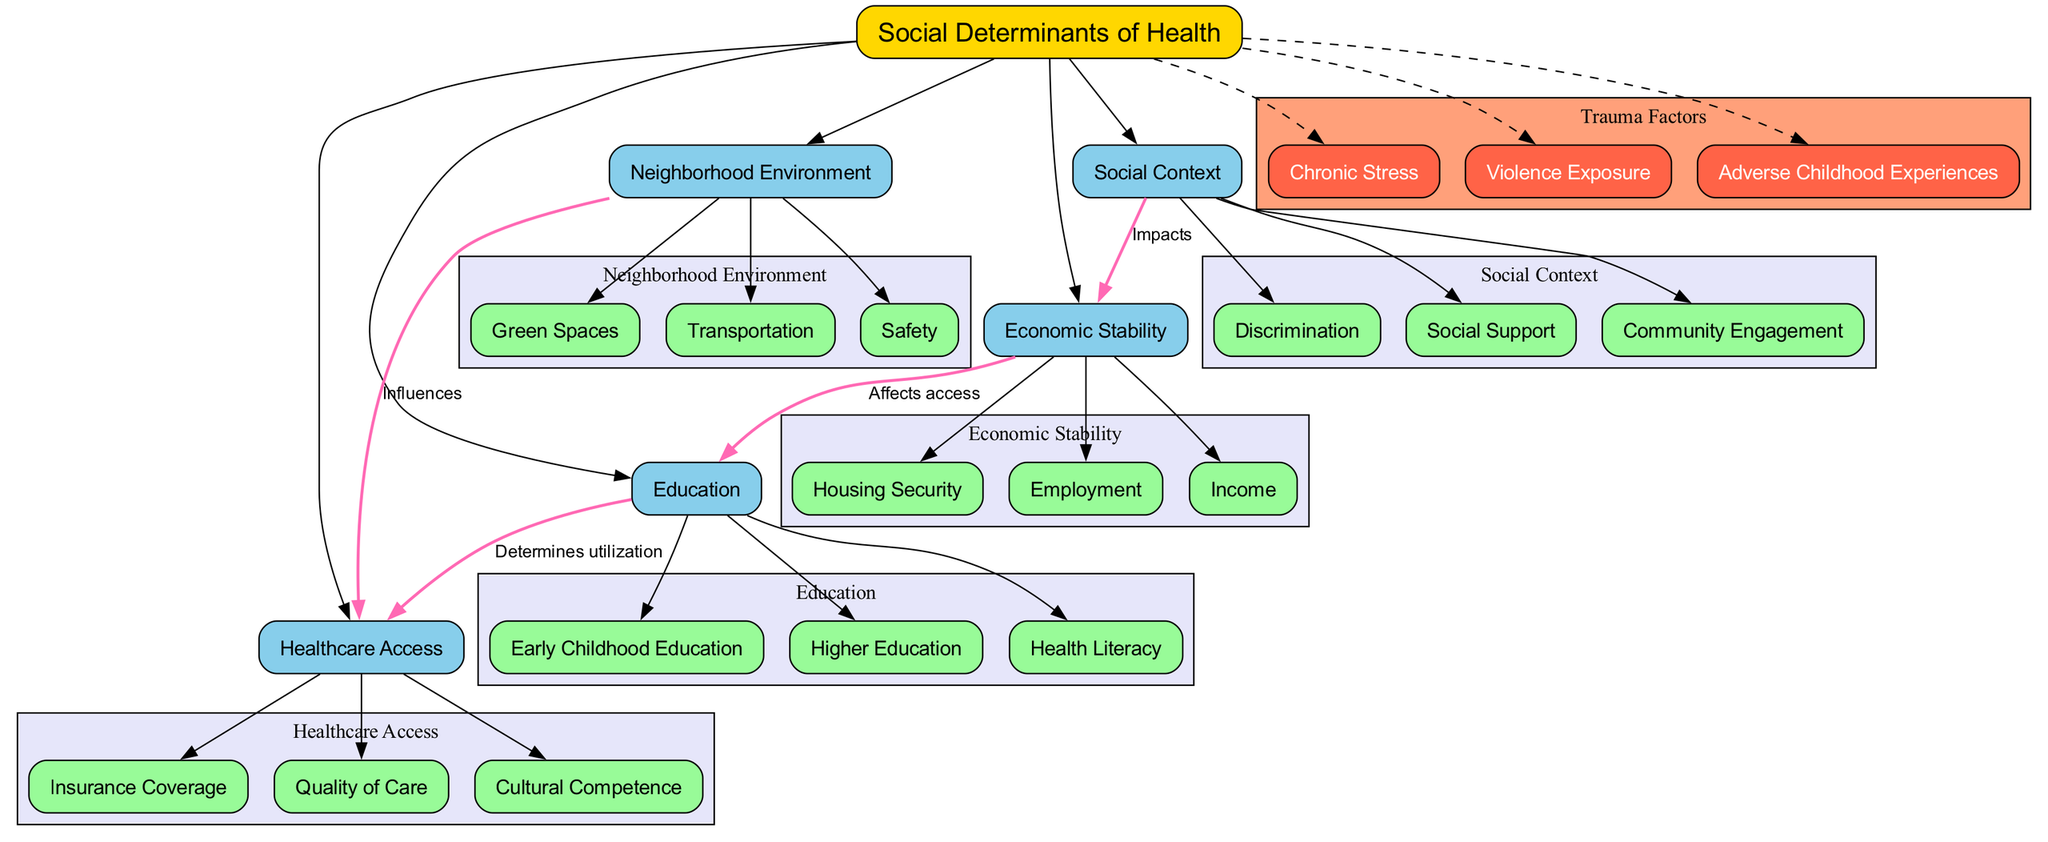What is the central topic of the diagram? The diagram explicitly states the central topic in the center node, labeled as "Social Determinants of Health."
Answer: Social Determinants of Health How many main categories are there in the diagram? By counting the nodes connected to the central topic, there are five main categories listed.
Answer: 5 What is one sub-element of Economic Stability? The diagram lists three sub-elements under Economic Stability; one of them, "Employment," can be identified.
Answer: Employment What type of connection exists between Neighborhood Environment and Healthcare Access? The connection is labeled as "Influences," indicating the nature of the relationship as visualized in the diagram.
Answer: Influences Which category affects access to Education? The diagram shows an edge connecting Economic Stability to Education, indicating that it affects access to Education.
Answer: Economic Stability What are the trauma factors listed in the diagram? The diagram provides three specific factors relating to trauma that can be directly found in the trauma factors cluster.
Answer: Chronic Stress, Violence Exposure, Adverse Childhood Experiences Which main category determines utilization of Healthcare Access? The diagram indicates that Education is the category that determines utilization of Healthcare Access, as noted by the connection labeled "Determines utilization."
Answer: Education How are Social Context and Economic Stability related? The diagram demonstrates a direct connection from Social Context to Economic Stability labeled "Impacts," showing their relationship.
Answer: Impacts What color represents the main categories in the diagram? The main categories are represented by nodes filled with a light blue color in the diagram.
Answer: Light blue 